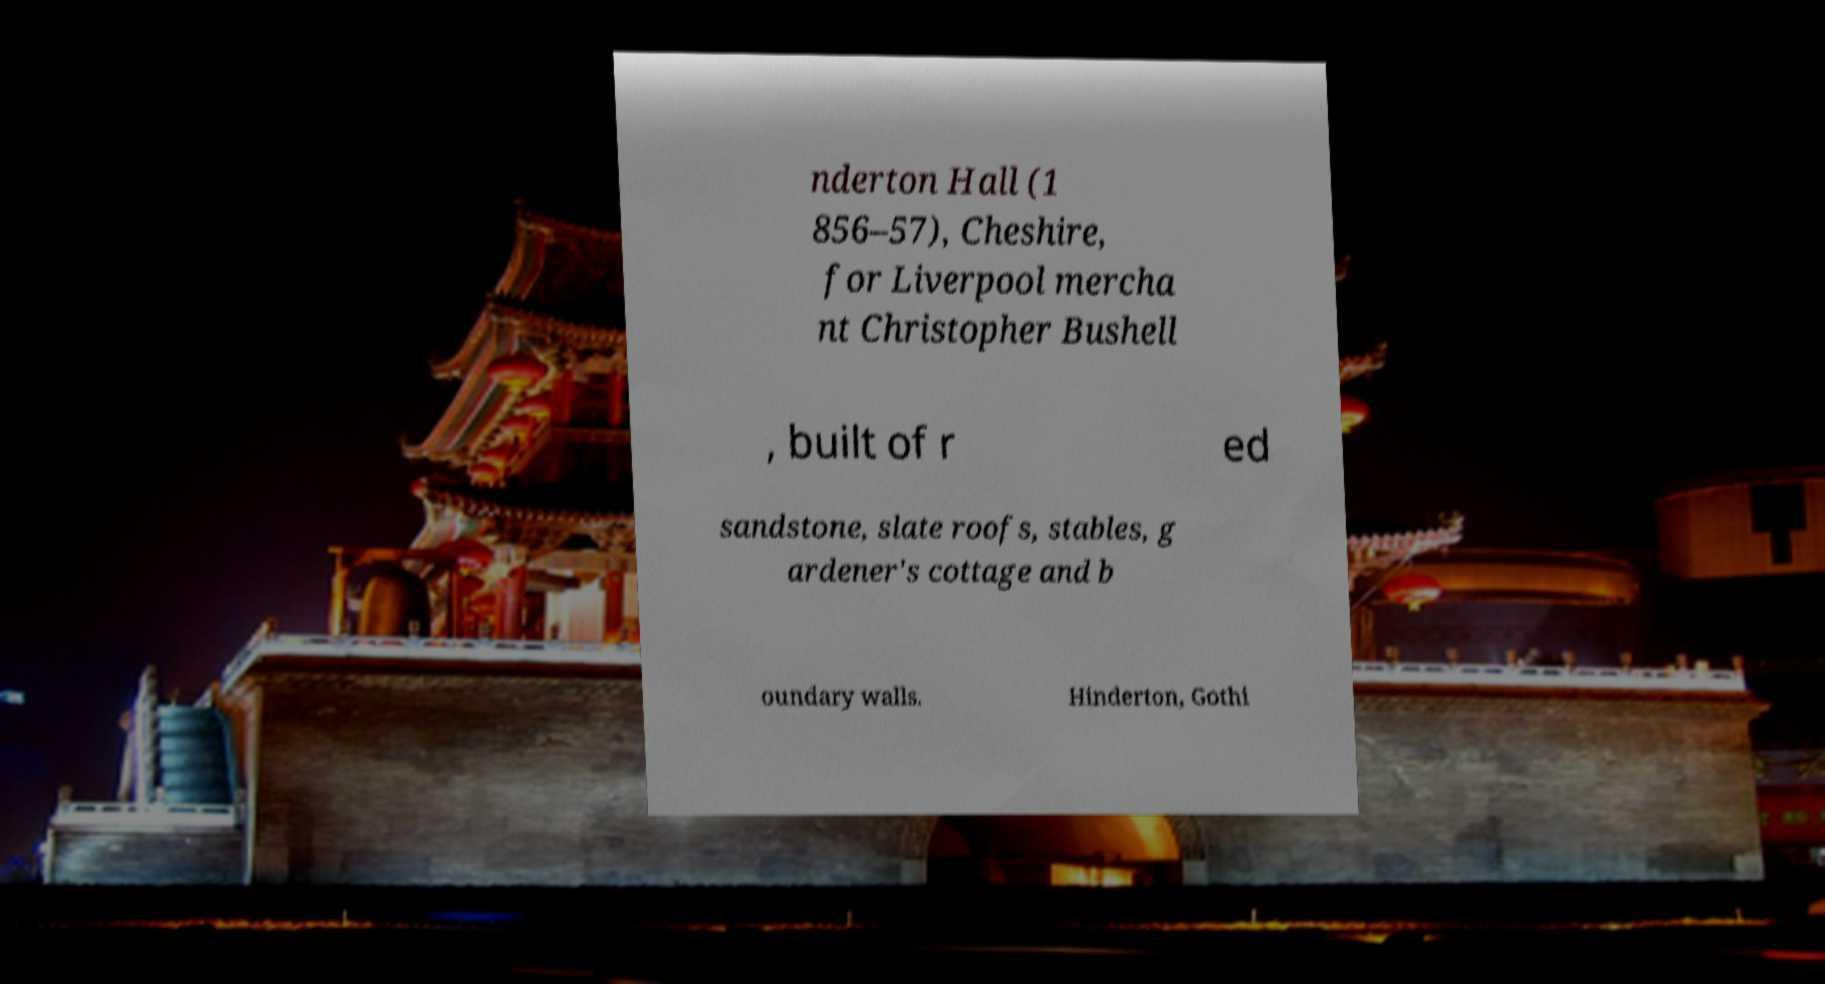Could you assist in decoding the text presented in this image and type it out clearly? nderton Hall (1 856–57), Cheshire, for Liverpool mercha nt Christopher Bushell , built of r ed sandstone, slate roofs, stables, g ardener's cottage and b oundary walls. Hinderton, Gothi 